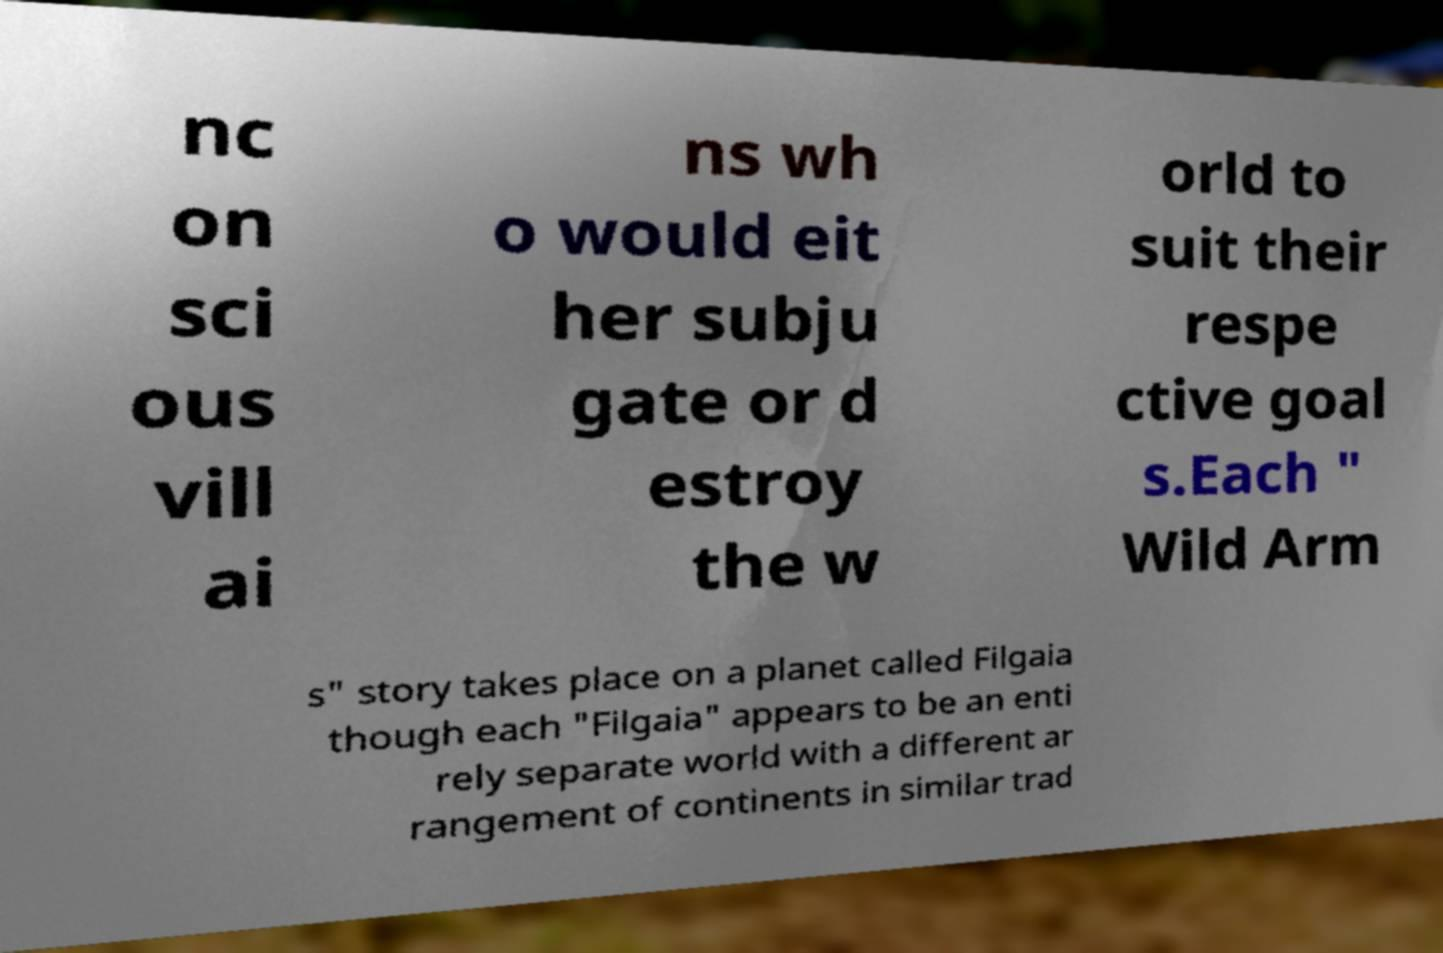What messages or text are displayed in this image? I need them in a readable, typed format. nc on sci ous vill ai ns wh o would eit her subju gate or d estroy the w orld to suit their respe ctive goal s.Each " Wild Arm s" story takes place on a planet called Filgaia though each "Filgaia" appears to be an enti rely separate world with a different ar rangement of continents in similar trad 